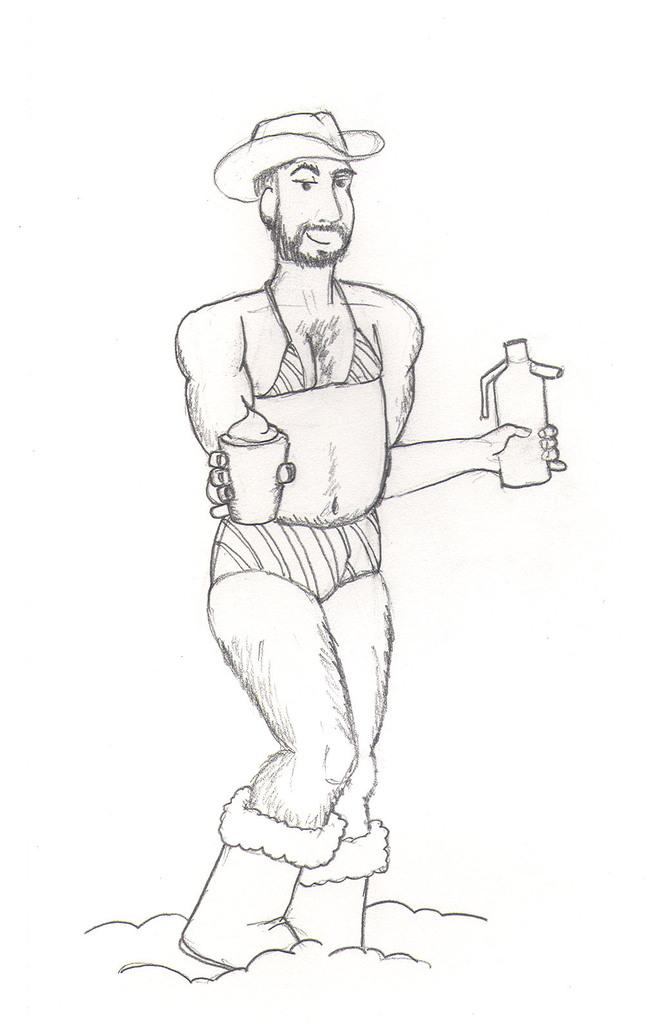What is depicted in the image? There is a sketch of a person in the image. What objects is the person holding? The person is holding a bottle and a cup. What color is the background of the image? The background of the image is white. What type of cart is visible in the image? There is no cart present in the image; it features a sketch of a person holding a bottle and a cup against a white background. 